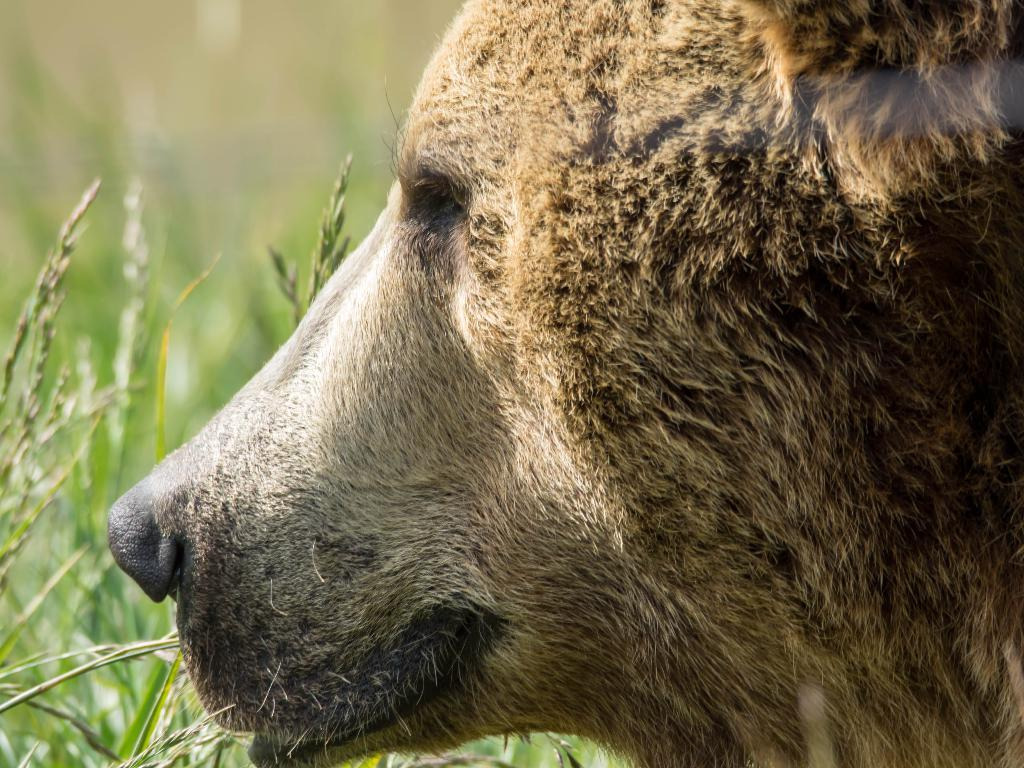What animal is present in the image? There is a bear in the image. How is the bear's face oriented in the image? The bear's face is shown in a side view. What type of environment is depicted in the background of the image? There is grass in the background of the image. What is the bear arguing about with the grass in the image? There is no indication of an argument or any interaction between the bear and the grass in the image. 